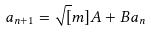<formula> <loc_0><loc_0><loc_500><loc_500>a _ { n + 1 } = \sqrt { [ } m ] { A + B a _ { n } }</formula> 